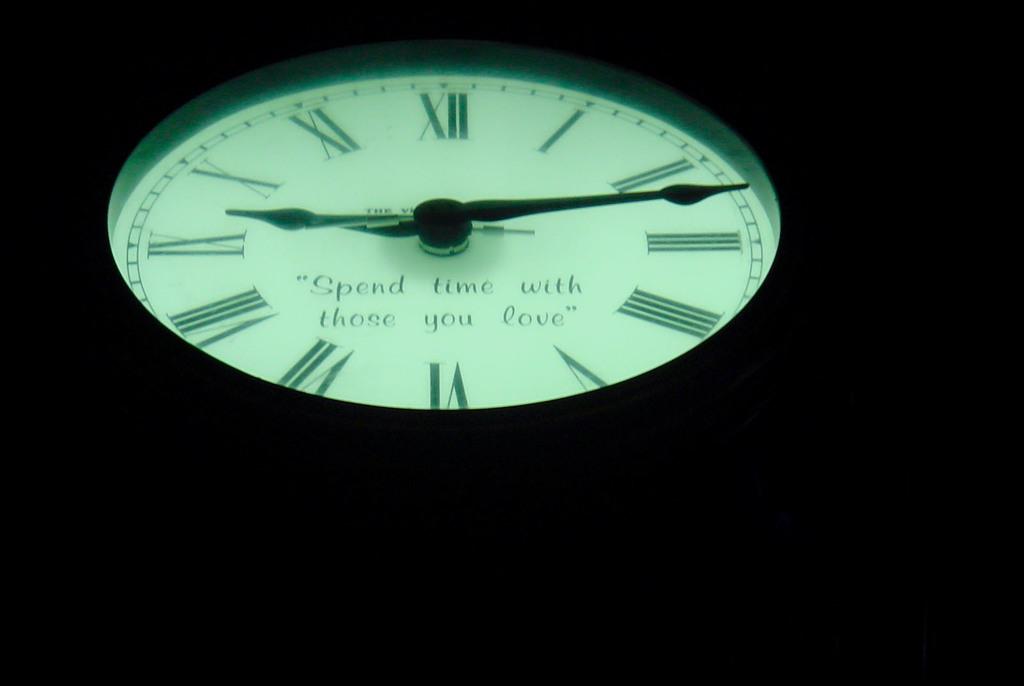Who should you spend time with?
Give a very brief answer. Those you love. What time is it?
Keep it short and to the point. 9:15. 